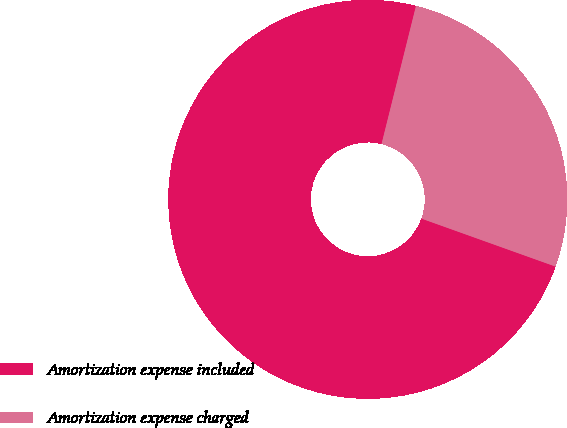Convert chart. <chart><loc_0><loc_0><loc_500><loc_500><pie_chart><fcel>Amortization expense included<fcel>Amortization expense charged<nl><fcel>73.42%<fcel>26.58%<nl></chart> 